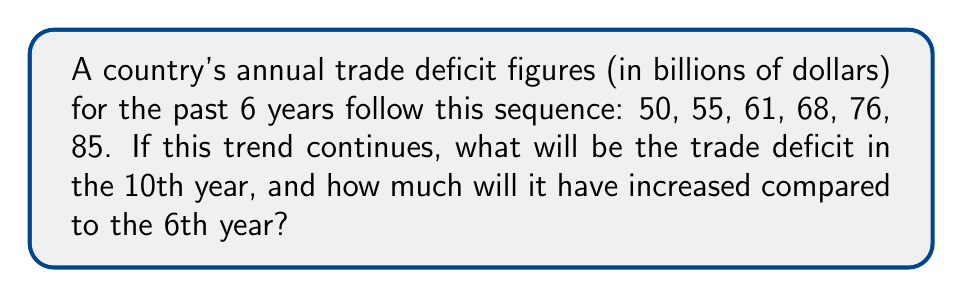Show me your answer to this math problem. 1. First, let's identify the pattern in the sequence:
   50, 55, 61, 68, 76, 85

2. Calculate the differences between consecutive terms:
   55 - 50 = 5
   61 - 55 = 6
   68 - 61 = 7
   76 - 68 = 8
   85 - 76 = 9

3. We can see that the difference is increasing by 1 each year. This forms an arithmetic sequence of second order.

4. The general formula for such a sequence is:
   $$a_n = a_1 + \frac{n(n-1)}{2}d_1 + \frac{(n-1)(n-2)}{2}d_2$$
   where $a_1$ is the first term, $d_1$ is the first difference, and $d_2$ is the difference of differences.

5. In our case:
   $a_1 = 50$
   $d_1 = 5$
   $d_2 = 1$

6. To find the 10th year, we substitute $n = 10$ into the formula:
   $$a_{10} = 50 + \frac{10(10-1)}{2}(5) + \frac{(10-1)(10-2)}{2}(1)$$
   $$= 50 + 45(5) + 36(1)$$
   $$= 50 + 225 + 36$$
   $$= 311$$

7. The increase compared to the 6th year:
   $$311 - 85 = 226$$
Answer: $311$ billion; increased by $226$ billion 